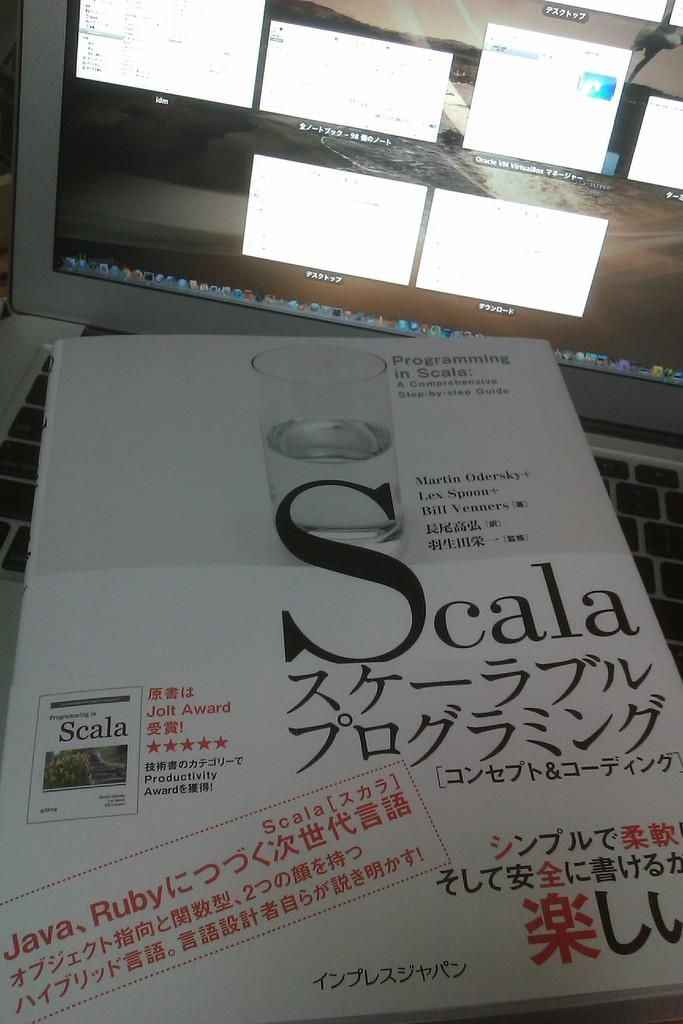Provide a one-sentence caption for the provided image. A step-by-step guide to programming with Scala is laying on a keyboard in front of a monitor. 